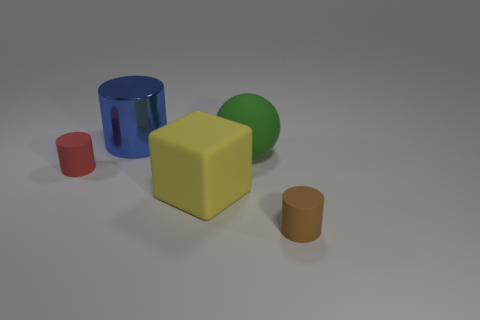How are the objects arranged in relation to each other? The objects are arranged on a flat surface with a clear pathway between them. From the left, we have a red cylinder, followed by a yellow block, a green sphere, and a large blue cylinder, with a small brown cylinder to the right. Their arrangement appears somewhat organized by height, transitioning from lower to higher starting with the smallest red cylinder. 